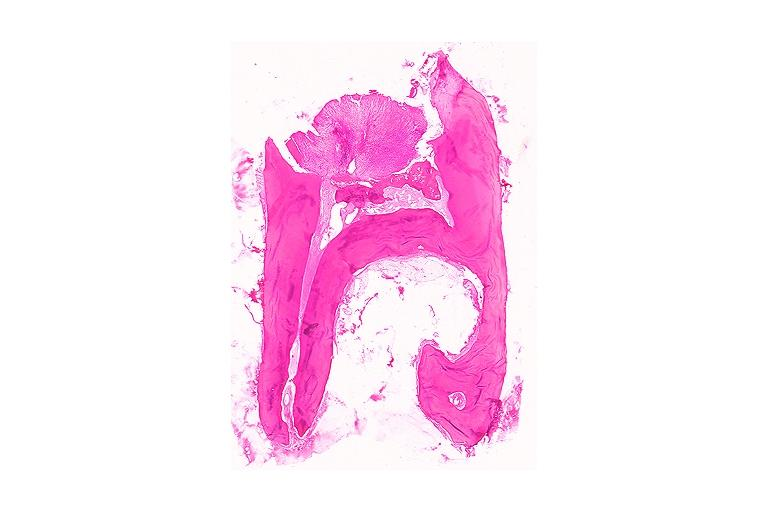s oral present?
Answer the question using a single word or phrase. Yes 